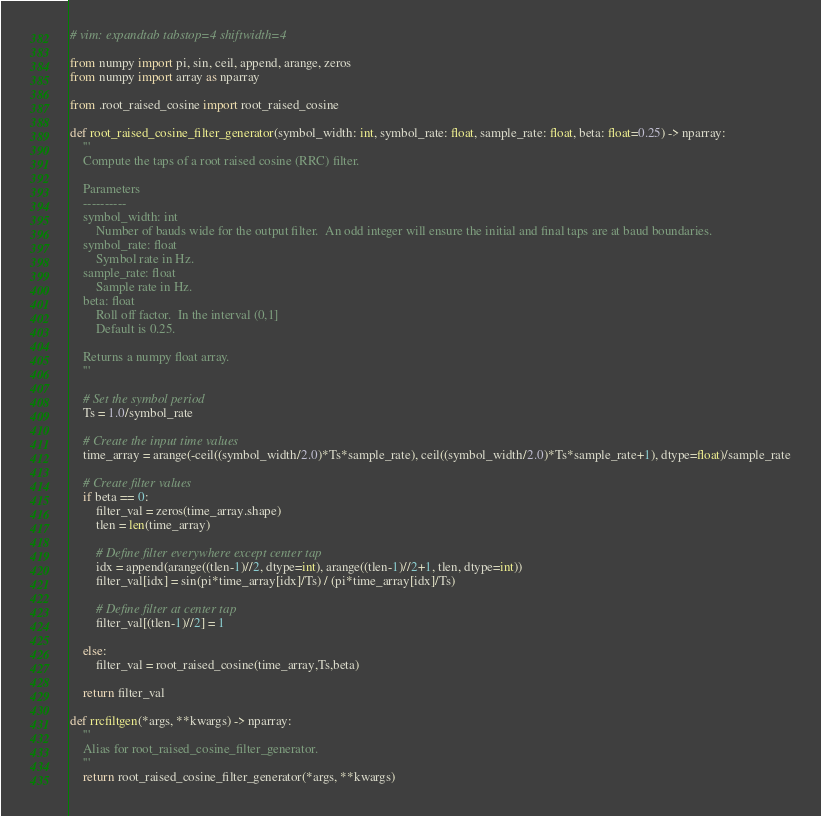<code> <loc_0><loc_0><loc_500><loc_500><_Python_># vim: expandtab tabstop=4 shiftwidth=4

from numpy import pi, sin, ceil, append, arange, zeros
from numpy import array as nparray

from .root_raised_cosine import root_raised_cosine

def root_raised_cosine_filter_generator(symbol_width: int, symbol_rate: float, sample_rate: float, beta: float=0.25) -> nparray:
    '''
    Compute the taps of a root raised cosine (RRC) filter.

    Parameters
    ----------
    symbol_width: int
        Number of bauds wide for the output filter.  An odd integer will ensure the initial and final taps are at baud boundaries.
    symbol_rate: float
        Symbol rate in Hz.
    sample_rate: float
        Sample rate in Hz.
    beta: float
        Roll off factor.  In the interval (0,1]
        Default is 0.25.

    Returns a numpy float array.
    '''

    # Set the symbol period
    Ts = 1.0/symbol_rate

    # Create the input time values
    time_array = arange(-ceil((symbol_width/2.0)*Ts*sample_rate), ceil((symbol_width/2.0)*Ts*sample_rate+1), dtype=float)/sample_rate

    # Create filter values
    if beta == 0:
        filter_val = zeros(time_array.shape)
        tlen = len(time_array)

        # Define filter everywhere except center tap
        idx = append(arange((tlen-1)//2, dtype=int), arange((tlen-1)//2+1, tlen, dtype=int))
        filter_val[idx] = sin(pi*time_array[idx]/Ts) / (pi*time_array[idx]/Ts)

        # Define filter at center tap
        filter_val[(tlen-1)//2] = 1

    else:
        filter_val = root_raised_cosine(time_array,Ts,beta)

    return filter_val

def rrcfiltgen(*args, **kwargs) -> nparray:
    '''
    Alias for root_raised_cosine_filter_generator.
    '''
    return root_raised_cosine_filter_generator(*args, **kwargs)
</code> 